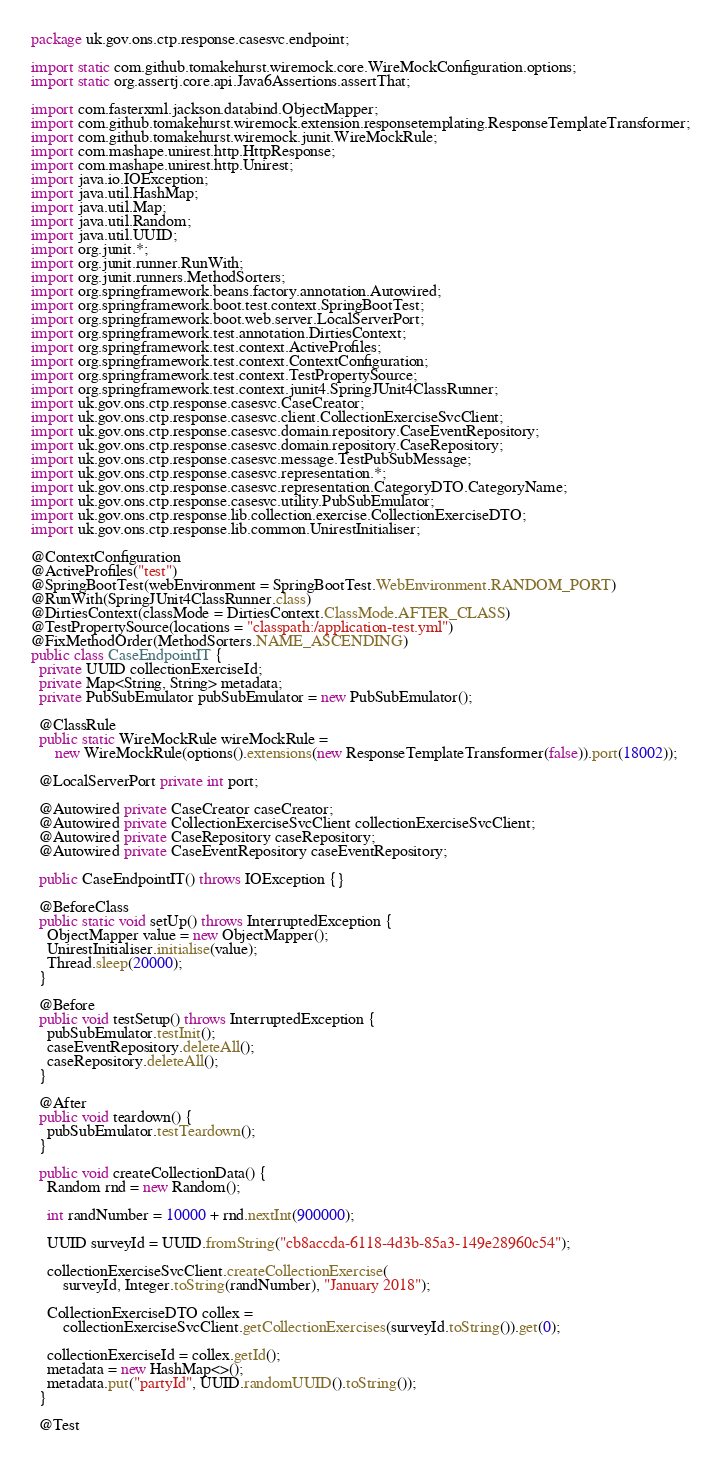<code> <loc_0><loc_0><loc_500><loc_500><_Java_>package uk.gov.ons.ctp.response.casesvc.endpoint;

import static com.github.tomakehurst.wiremock.core.WireMockConfiguration.options;
import static org.assertj.core.api.Java6Assertions.assertThat;

import com.fasterxml.jackson.databind.ObjectMapper;
import com.github.tomakehurst.wiremock.extension.responsetemplating.ResponseTemplateTransformer;
import com.github.tomakehurst.wiremock.junit.WireMockRule;
import com.mashape.unirest.http.HttpResponse;
import com.mashape.unirest.http.Unirest;
import java.io.IOException;
import java.util.HashMap;
import java.util.Map;
import java.util.Random;
import java.util.UUID;
import org.junit.*;
import org.junit.runner.RunWith;
import org.junit.runners.MethodSorters;
import org.springframework.beans.factory.annotation.Autowired;
import org.springframework.boot.test.context.SpringBootTest;
import org.springframework.boot.web.server.LocalServerPort;
import org.springframework.test.annotation.DirtiesContext;
import org.springframework.test.context.ActiveProfiles;
import org.springframework.test.context.ContextConfiguration;
import org.springframework.test.context.TestPropertySource;
import org.springframework.test.context.junit4.SpringJUnit4ClassRunner;
import uk.gov.ons.ctp.response.casesvc.CaseCreator;
import uk.gov.ons.ctp.response.casesvc.client.CollectionExerciseSvcClient;
import uk.gov.ons.ctp.response.casesvc.domain.repository.CaseEventRepository;
import uk.gov.ons.ctp.response.casesvc.domain.repository.CaseRepository;
import uk.gov.ons.ctp.response.casesvc.message.TestPubSubMessage;
import uk.gov.ons.ctp.response.casesvc.representation.*;
import uk.gov.ons.ctp.response.casesvc.representation.CategoryDTO.CategoryName;
import uk.gov.ons.ctp.response.casesvc.utility.PubSubEmulator;
import uk.gov.ons.ctp.response.lib.collection.exercise.CollectionExerciseDTO;
import uk.gov.ons.ctp.response.lib.common.UnirestInitialiser;

@ContextConfiguration
@ActiveProfiles("test")
@SpringBootTest(webEnvironment = SpringBootTest.WebEnvironment.RANDOM_PORT)
@RunWith(SpringJUnit4ClassRunner.class)
@DirtiesContext(classMode = DirtiesContext.ClassMode.AFTER_CLASS)
@TestPropertySource(locations = "classpath:/application-test.yml")
@FixMethodOrder(MethodSorters.NAME_ASCENDING)
public class CaseEndpointIT {
  private UUID collectionExerciseId;
  private Map<String, String> metadata;
  private PubSubEmulator pubSubEmulator = new PubSubEmulator();

  @ClassRule
  public static WireMockRule wireMockRule =
      new WireMockRule(options().extensions(new ResponseTemplateTransformer(false)).port(18002));

  @LocalServerPort private int port;

  @Autowired private CaseCreator caseCreator;
  @Autowired private CollectionExerciseSvcClient collectionExerciseSvcClient;
  @Autowired private CaseRepository caseRepository;
  @Autowired private CaseEventRepository caseEventRepository;

  public CaseEndpointIT() throws IOException {}

  @BeforeClass
  public static void setUp() throws InterruptedException {
    ObjectMapper value = new ObjectMapper();
    UnirestInitialiser.initialise(value);
    Thread.sleep(20000);
  }

  @Before
  public void testSetup() throws InterruptedException {
    pubSubEmulator.testInit();
    caseEventRepository.deleteAll();
    caseRepository.deleteAll();
  }

  @After
  public void teardown() {
    pubSubEmulator.testTeardown();
  }

  public void createCollectionData() {
    Random rnd = new Random();

    int randNumber = 10000 + rnd.nextInt(900000);

    UUID surveyId = UUID.fromString("cb8accda-6118-4d3b-85a3-149e28960c54");

    collectionExerciseSvcClient.createCollectionExercise(
        surveyId, Integer.toString(randNumber), "January 2018");

    CollectionExerciseDTO collex =
        collectionExerciseSvcClient.getCollectionExercises(surveyId.toString()).get(0);

    collectionExerciseId = collex.getId();
    metadata = new HashMap<>();
    metadata.put("partyId", UUID.randomUUID().toString());
  }

  @Test</code> 